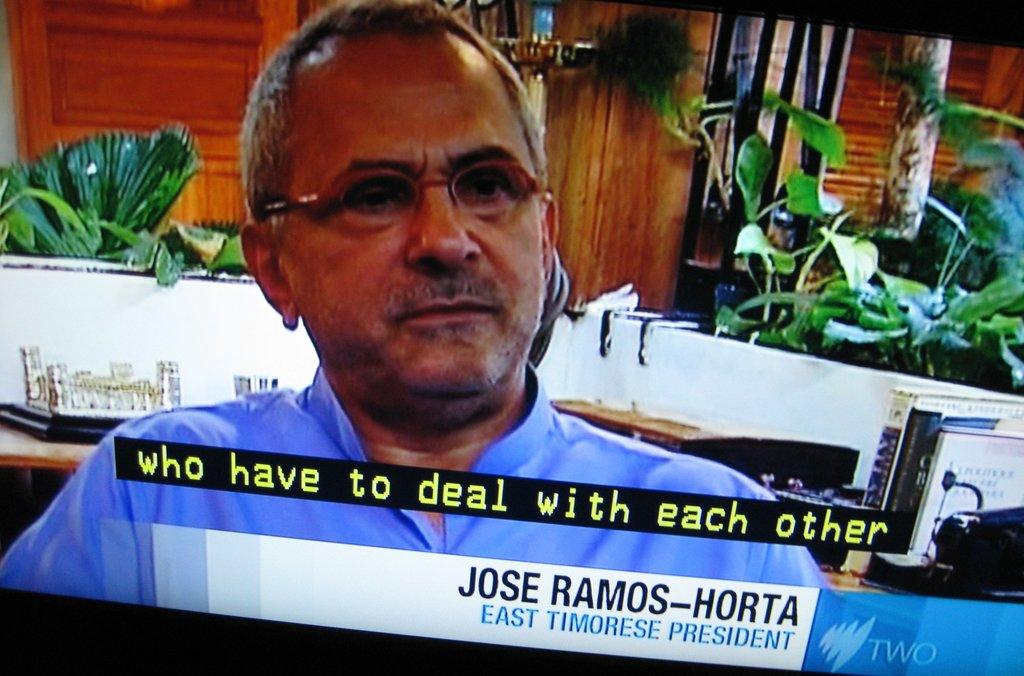Who is the main subject in the image? There is a man on the screen. What can be seen behind the man? Books, house plants, and a wooden wall are visible behind the man. Are there any written words on the screen? Yes, there are subtitles on the screen. What type of cake is being served in the image? There is no cake present in the image. What route is the man taking in the image? The image does not depict the man taking a route, as it is a still image. 